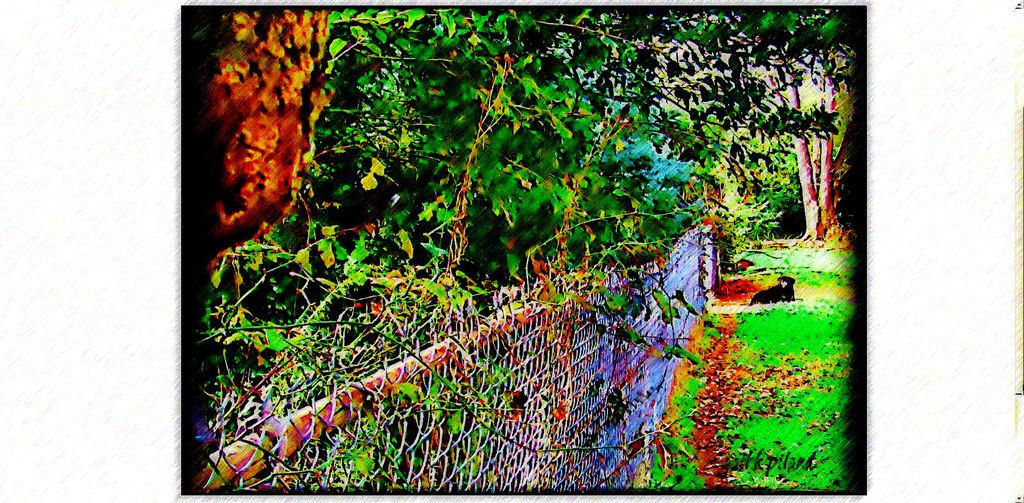What is located at the front of the image? There is fencing in the front of the image. What type of vegetation is on the right side of the image? There is grass on the right side of the image. What can be seen in the background of the image? There are trees in the background of the image. Can you describe the main subject in the middle of the image? It appears that there is a dog in the middle of the image. What type of fuel is the dog using to run in the image? Dogs do not use fuel to run; they use their own energy. Is there a collar visible on the dog in the image? The provided facts do not mention a collar, so we cannot determine if one is present. 